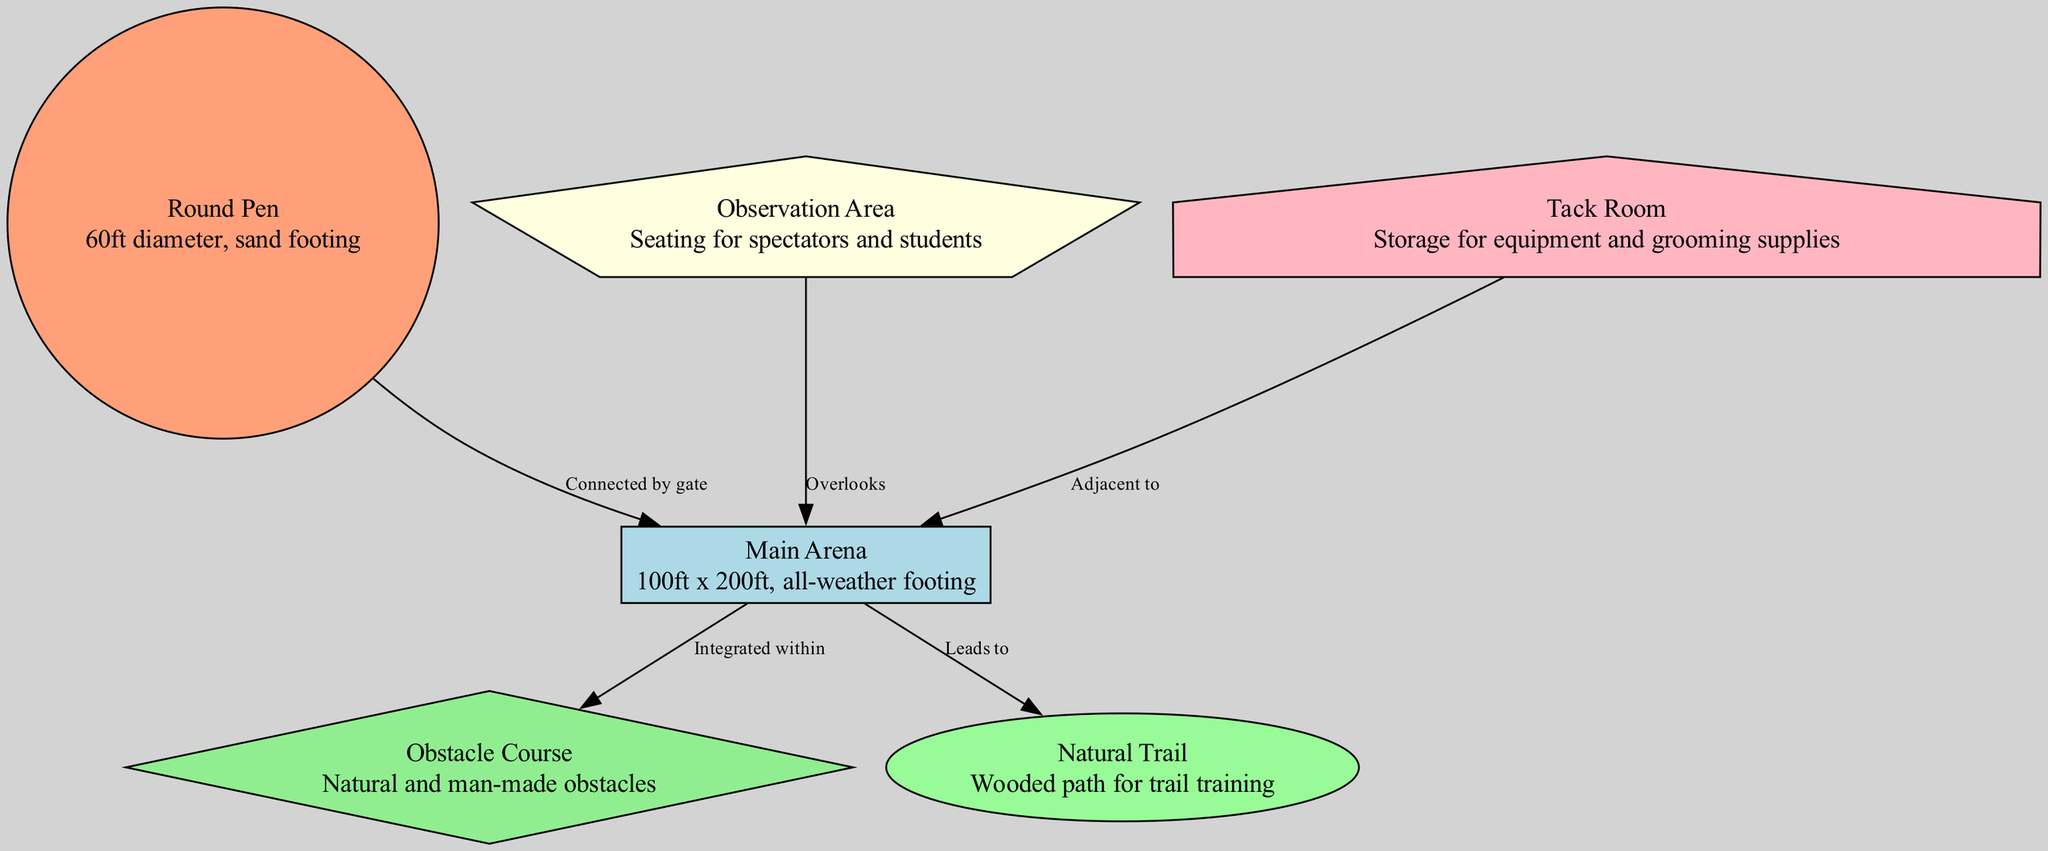What is the diameter of the Round Pen? The Round Pen has a specific detail listed, stating it is 60ft in diameter. This information is directly associated with the node labeled "Round Pen."
Answer: 60ft How big is the Main Arena? The dimensions of the Main Arena are provided in the details of its corresponding node. It states that the Main Arena measures 100ft x 200ft.
Answer: 100ft x 200ft What area is adjacent to the Main Arena? By checking the connections in the diagram, the "Tack Room" is indicated as being adjacent to the Main Arena. This relationship is specified in the edge description between node 5 and node 2.
Answer: Tack Room How many nodes are in the diagram? To determine the number of nodes, simply count the entries in the "nodes" data. There are six nodes listed.
Answer: 6 Which area leads to the Natural Trail? The diagram indicates that the Main Arena has a direct connection to the Natural Trail. This is shown in the edge labeled "Leads to" from node 2 to node 6.
Answer: Main Arena What shapes represent the Obstacle Course? In the diagram's specifications for node styles, the Obstacle Course is defined to be represented as a diamond shape.
Answer: Diamond Which area overlooks the Main Arena? The Observation Area is detailed in the connections as overlooking the Main Arena, as indicated by the edge description from node 4 to node 2.
Answer: Observation Area What are the types of obstacles in the Obstacle Course? The details of the Obstacle Course node specify that it includes both natural and man-made obstacles, reflecting the training techniques integrated into the layout.
Answer: Natural and man-made How is the Round Pen connected to the Main Arena? The Round Pen is indicated to be connected to the Main Arena by a gate, as specified in the edge description between node 1 and node 2.
Answer: Gate 